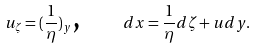<formula> <loc_0><loc_0><loc_500><loc_500>u _ { \zeta } = ( \frac { 1 } { \eta } ) _ { y } \text {, \quad } d x = \frac { 1 } { \eta } d \zeta + u d y .</formula> 